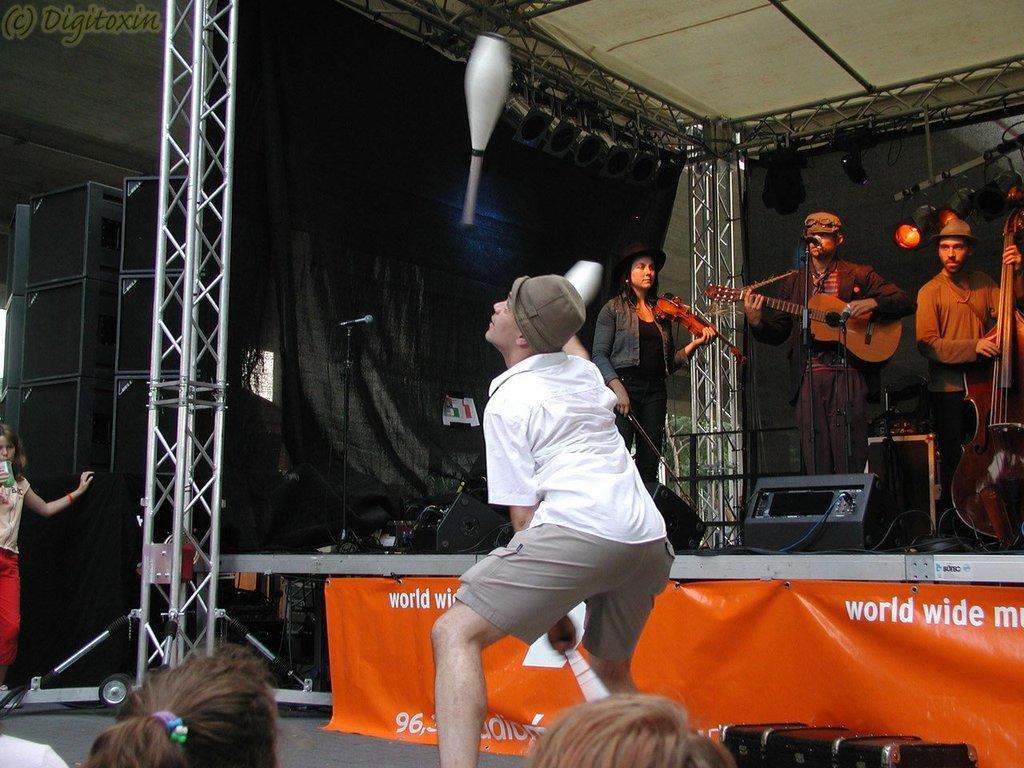Could you give a brief overview of what you see in this image? There is a man wearing a hat standing on the floor. In the background on the stage there are some people standing and playing musical instruments in their hands, in front of mic. There is a woman in the left side. In the background there is a dark black color cloth. There are some speakers here. 